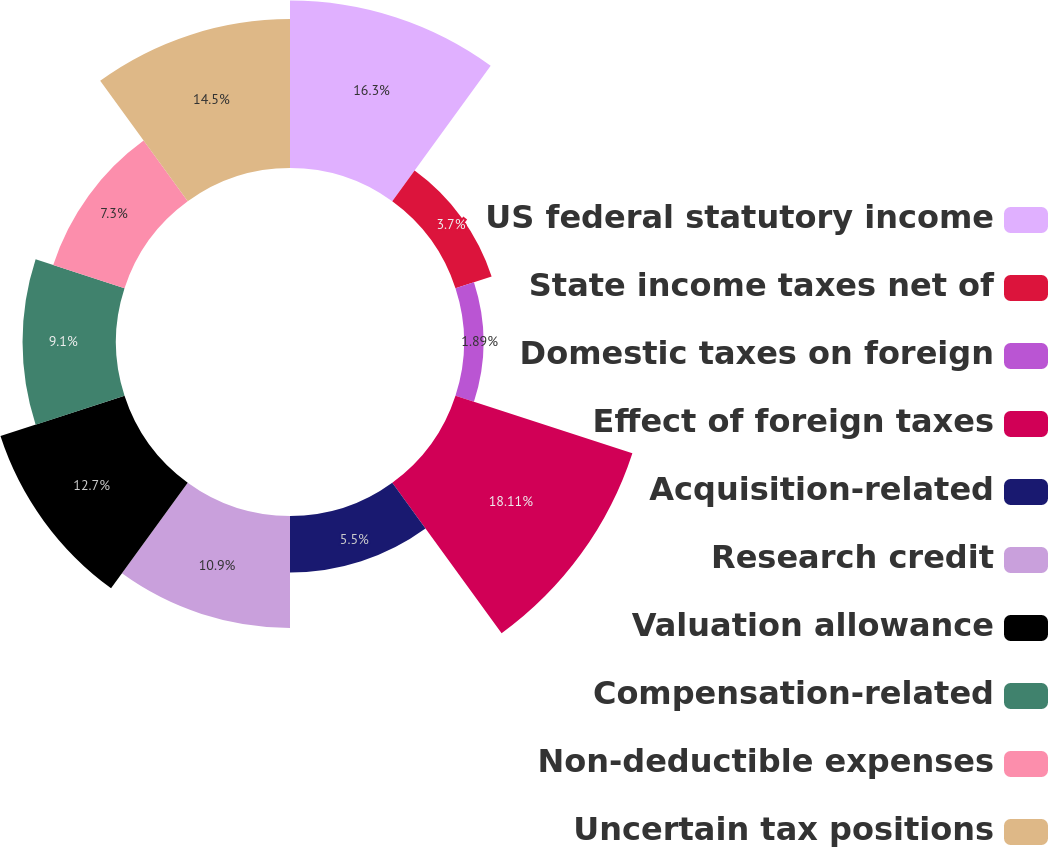Convert chart to OTSL. <chart><loc_0><loc_0><loc_500><loc_500><pie_chart><fcel>US federal statutory income<fcel>State income taxes net of<fcel>Domestic taxes on foreign<fcel>Effect of foreign taxes<fcel>Acquisition-related<fcel>Research credit<fcel>Valuation allowance<fcel>Compensation-related<fcel>Non-deductible expenses<fcel>Uncertain tax positions<nl><fcel>16.3%<fcel>3.7%<fcel>1.89%<fcel>18.11%<fcel>5.5%<fcel>10.9%<fcel>12.7%<fcel>9.1%<fcel>7.3%<fcel>14.5%<nl></chart> 